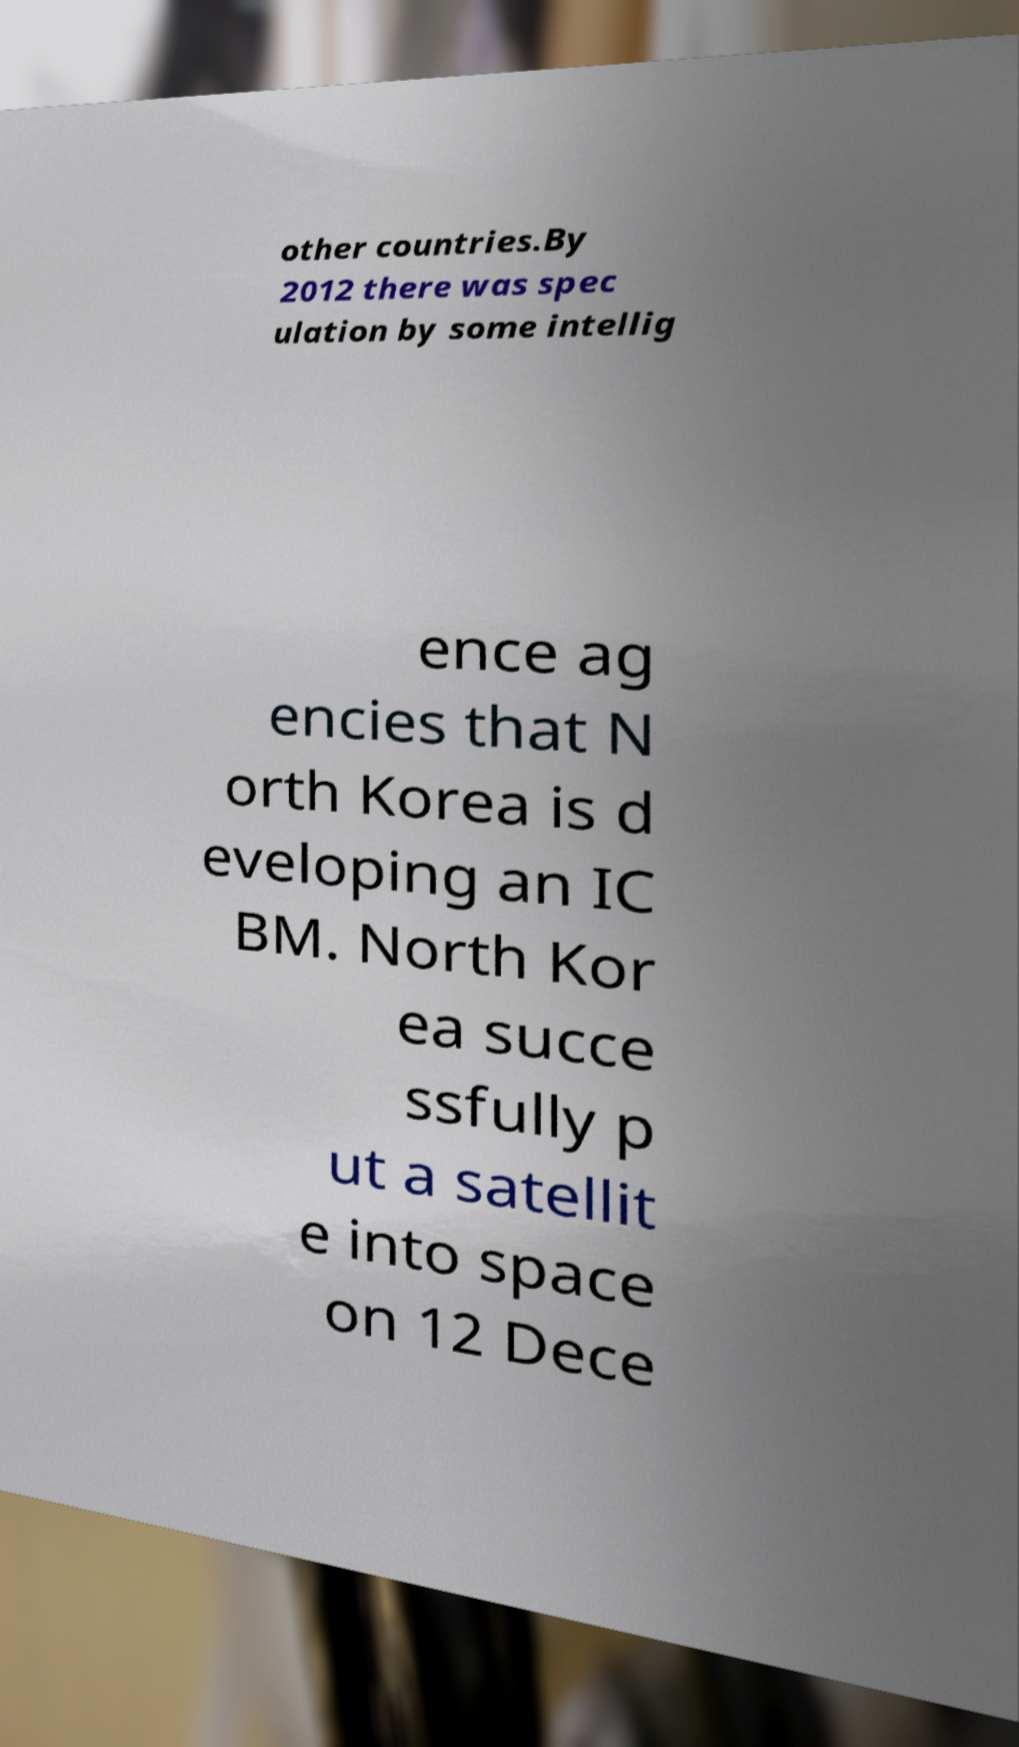Please identify and transcribe the text found in this image. other countries.By 2012 there was spec ulation by some intellig ence ag encies that N orth Korea is d eveloping an IC BM. North Kor ea succe ssfully p ut a satellit e into space on 12 Dece 